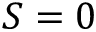Convert formula to latex. <formula><loc_0><loc_0><loc_500><loc_500>S = 0</formula> 